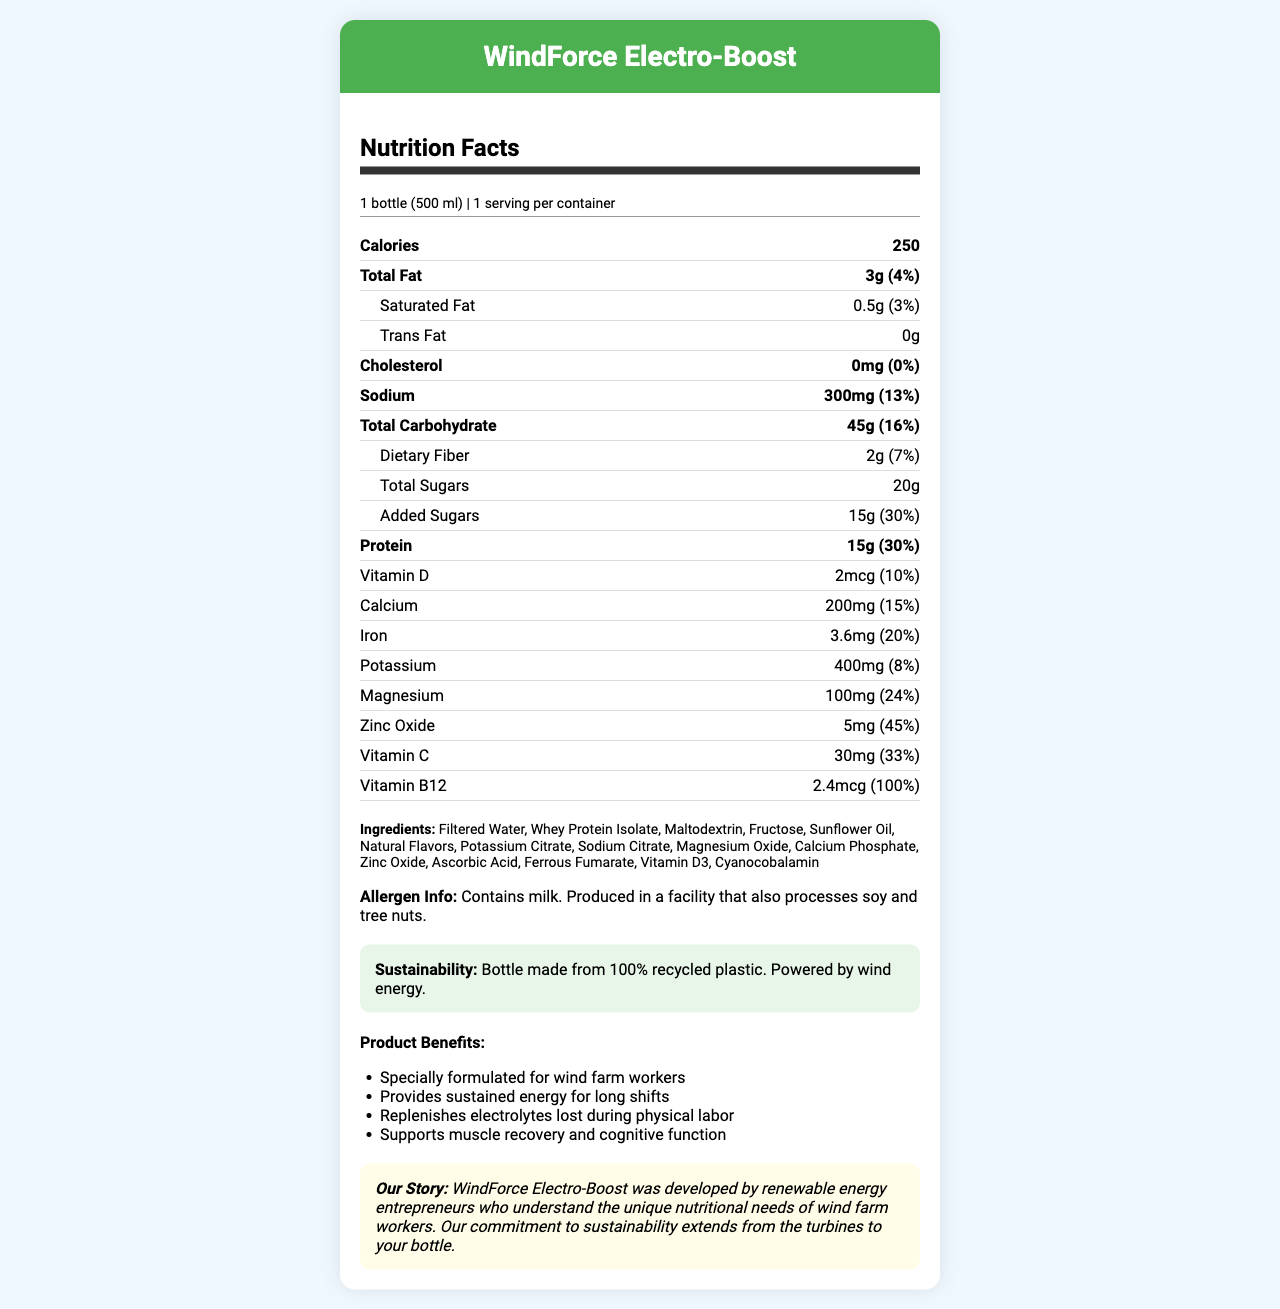what is the serving size of WindForce Electro-Boost? The serving size is clearly stated near the top of the nutrition facts section as "1 bottle (500 ml)".
Answer: 1 bottle (500 ml) how many calories are in one serving of this beverage? The calorie content is listed under the "Calories" section in the nutrition facts.
Answer: 250 calories how much protein does this beverage provide per serving? The amount of protein per serving is listed under the "Protein" section as 15g.
Answer: 15g what percentage of the daily value of sodium does one serving contain? The daily value percentage for sodium is given as 13% next to the sodium amount.
Answer: 13% which ingredient in this beverage might be a concern for someone with a milk allergy? The allergen information states that the product contains milk, and Whey Protein Isolate is derived from milk.
Answer: Whey Protein Isolate triage the following ingredients in the drink: A. Fructose, B. Zinc Oxide, C. Sunflower Oil, D. Vitamin D3 Zinc Oxide and Vitamin D3 are both mineral/vitamin additives while Fructose and Sunflower Oil are more general ingredients.
Answer: B, D does this product contain added sugars? The nutrition facts label indicates that there are 15g of added sugars.
Answer: Yes how many grams of total carbohydrates are in one serving of WindForce Electro-Boost? The total amount of carbohydrates is specified as 45g in the nutrition facts.
Answer: 45g what is the brand story of WindForce Electro-Boost? The brand story is included at the bottom of the nutrition facts section in italic text.
Answer: Developed by renewable energy entrepreneurs who understand the unique nutritional needs of wind farm workers, and committed to sustainability from turbines to bottles. which of these nutrients has the highest daily value percentage per serving? A. Iron, B. Magnesium, C. Zinc Oxide, D. Vitamin B12 Vitamin B12 has a daily value of 100%, which is higher than Iron (20%), Magnesium (24%), and Zinc Oxide (45%).
Answer: D. Vitamin B12 does this beverage contribute to calcium intake by 15% daily value? The nutrition facts indicate it has 15% of the daily value for calcium.
Answer: Yes is there any information about vitamin A content in WindForce Electro-Boost? The nutrition facts label does not list vitamin A content or daily value.
Answer: Not enough information summarize the key features of WindForce Electro-Boost. WindForce Electro-Boost is tailored for wind farm workers' nutritional needs and sustainability, offering a balanced nutrient profile to support energy and recovery.
Answer: WindForce Electro-Boost is a meal replacement beverage designed for wind farm workers, providing 250 calories, 15g of protein, 45g of carbohydrates, and essential electrolytes. It contains added sugars, no trans fat, and has various vitamins and minerals. The product is packaged in a sustainable bottle made from 100% recycled plastic and is powered by wind energy. 